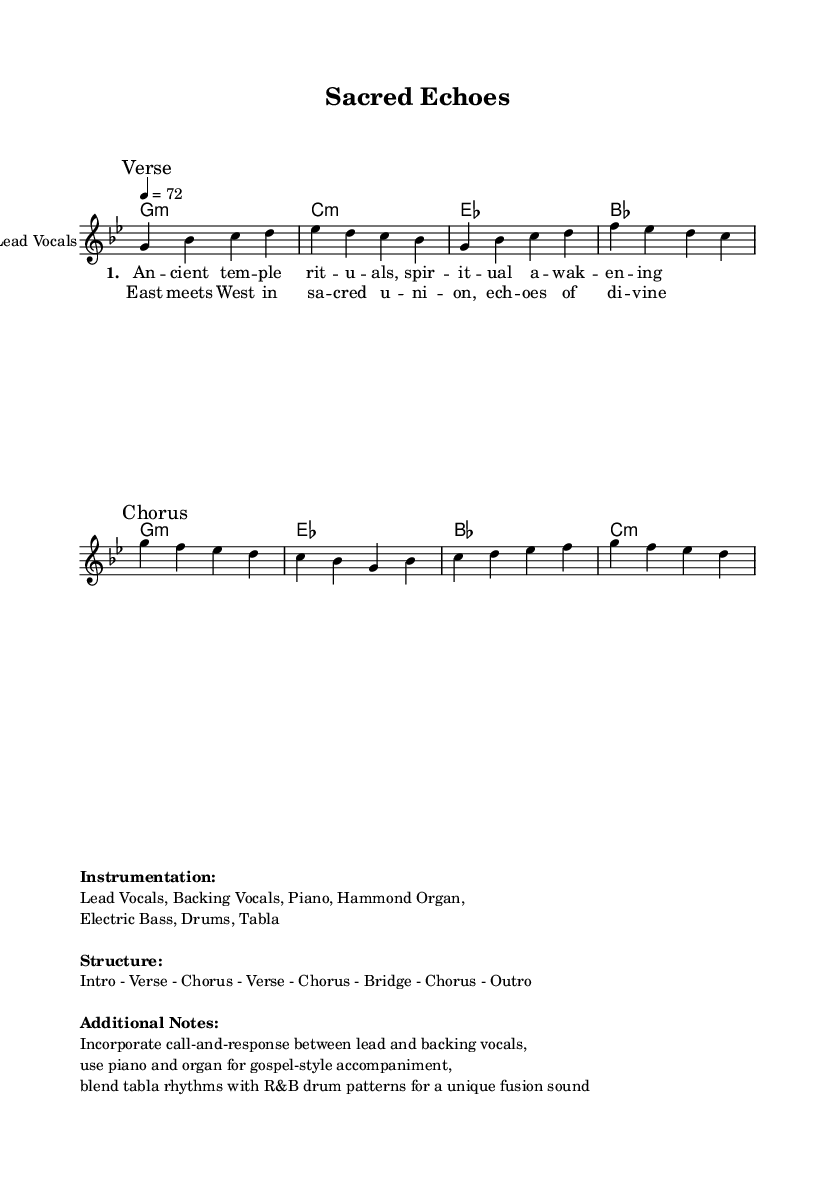What is the key signature of this music? The key signature indicates the scale used in the piece. In this score, the key signature is G minor, which includes two flats (B flat and E flat).
Answer: G minor What is the time signature? The time signature is indicated at the beginning of the score. In this case, it is 4/4, meaning there are four beats in each measure and the quarter note gets one beat.
Answer: 4/4 What is the tempo marking? The tempo marking specifies the speed of the music. Here, it is marked as a quarter note equals 72 beats per minute.
Answer: 72 How many verses are present in the structure? By examining the structure provided in the markup, we see the order is "Intro - Verse - Chorus - Verse - Chorus - Bridge - Chorus - Outro", indicating there are two verses.
Answer: 2 What instrumentation is used in this piece? The instrumentation section lists the instruments used in the music. The score mentions Lead Vocals, Backing Vocals, Piano, Hammond Organ, Electric Bass, Drums, and Tabla.
Answer: Lead Vocals, Backing Vocals, Piano, Hammond Organ, Electric Bass, Drums, Tabla What is the primary lyrical theme in the song? The lyrics explore themes of ancient rituals and spiritual awakening, indicated in the verse lines. The first line specifically mentions "Ancient temple rituals" and "spiritual awakening".
Answer: Spiritual awakening 